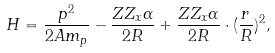<formula> <loc_0><loc_0><loc_500><loc_500>H = \frac { p ^ { 2 } } { 2 A m _ { p } } - \frac { Z Z _ { x } \alpha } { 2 R } + \frac { Z Z _ { x } \alpha } { 2 R } \cdot ( \frac { r } { R } ) ^ { 2 } ,</formula> 